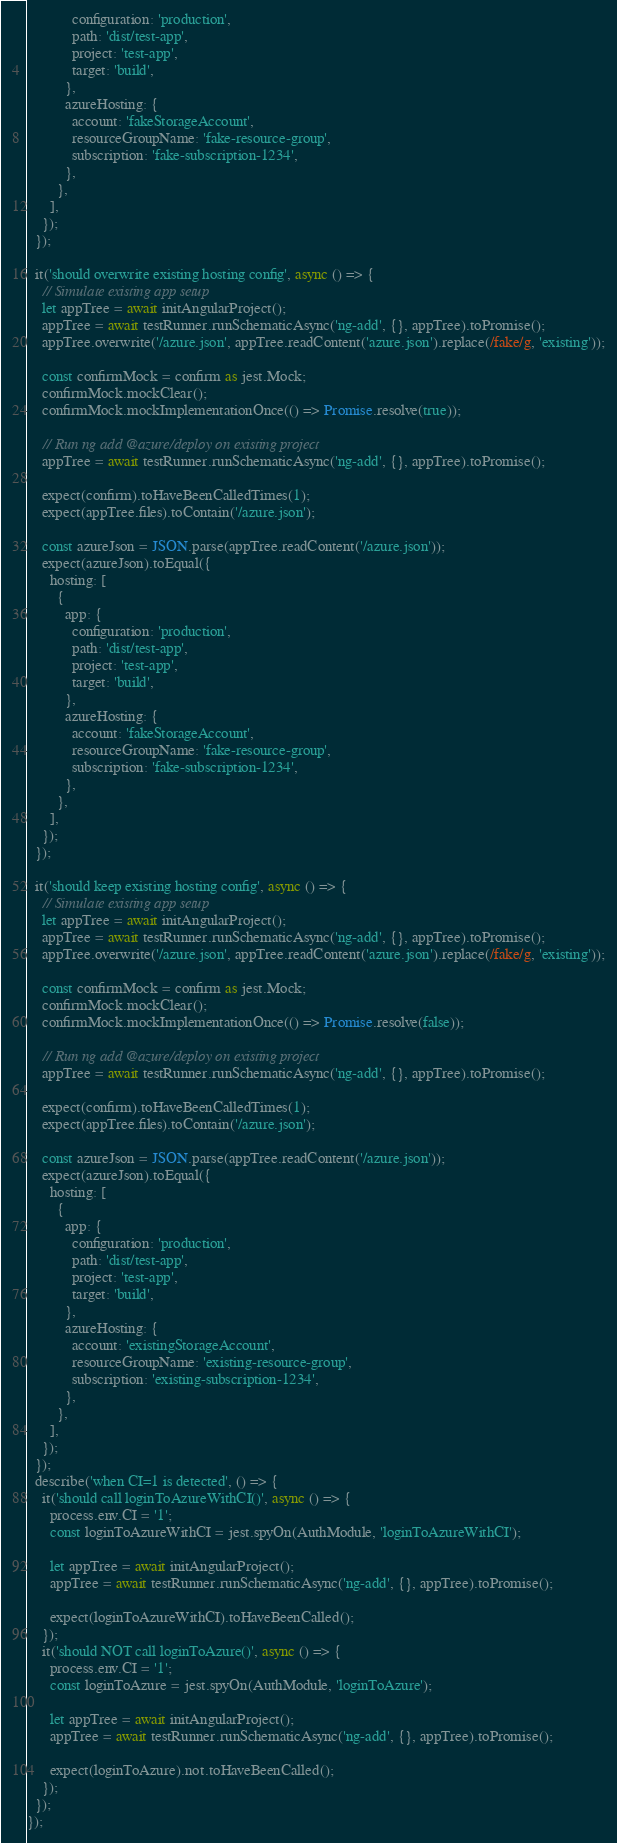Convert code to text. <code><loc_0><loc_0><loc_500><loc_500><_TypeScript_>            configuration: 'production',
            path: 'dist/test-app',
            project: 'test-app',
            target: 'build',
          },
          azureHosting: {
            account: 'fakeStorageAccount',
            resourceGroupName: 'fake-resource-group',
            subscription: 'fake-subscription-1234',
          },
        },
      ],
    });
  });

  it('should overwrite existing hosting config', async () => {
    // Simulate existing app setup
    let appTree = await initAngularProject();
    appTree = await testRunner.runSchematicAsync('ng-add', {}, appTree).toPromise();
    appTree.overwrite('/azure.json', appTree.readContent('azure.json').replace(/fake/g, 'existing'));

    const confirmMock = confirm as jest.Mock;
    confirmMock.mockClear();
    confirmMock.mockImplementationOnce(() => Promise.resolve(true));

    // Run ng add @azure/deploy on existing project
    appTree = await testRunner.runSchematicAsync('ng-add', {}, appTree).toPromise();

    expect(confirm).toHaveBeenCalledTimes(1);
    expect(appTree.files).toContain('/azure.json');

    const azureJson = JSON.parse(appTree.readContent('/azure.json'));
    expect(azureJson).toEqual({
      hosting: [
        {
          app: {
            configuration: 'production',
            path: 'dist/test-app',
            project: 'test-app',
            target: 'build',
          },
          azureHosting: {
            account: 'fakeStorageAccount',
            resourceGroupName: 'fake-resource-group',
            subscription: 'fake-subscription-1234',
          },
        },
      ],
    });
  });

  it('should keep existing hosting config', async () => {
    // Simulate existing app setup
    let appTree = await initAngularProject();
    appTree = await testRunner.runSchematicAsync('ng-add', {}, appTree).toPromise();
    appTree.overwrite('/azure.json', appTree.readContent('azure.json').replace(/fake/g, 'existing'));

    const confirmMock = confirm as jest.Mock;
    confirmMock.mockClear();
    confirmMock.mockImplementationOnce(() => Promise.resolve(false));

    // Run ng add @azure/deploy on existing project
    appTree = await testRunner.runSchematicAsync('ng-add', {}, appTree).toPromise();

    expect(confirm).toHaveBeenCalledTimes(1);
    expect(appTree.files).toContain('/azure.json');

    const azureJson = JSON.parse(appTree.readContent('/azure.json'));
    expect(azureJson).toEqual({
      hosting: [
        {
          app: {
            configuration: 'production',
            path: 'dist/test-app',
            project: 'test-app',
            target: 'build',
          },
          azureHosting: {
            account: 'existingStorageAccount',
            resourceGroupName: 'existing-resource-group',
            subscription: 'existing-subscription-1234',
          },
        },
      ],
    });
  });
  describe('when CI=1 is detected', () => {
    it('should call loginToAzureWithCI()', async () => {
      process.env.CI = '1';
      const loginToAzureWithCI = jest.spyOn(AuthModule, 'loginToAzureWithCI');

      let appTree = await initAngularProject();
      appTree = await testRunner.runSchematicAsync('ng-add', {}, appTree).toPromise();

      expect(loginToAzureWithCI).toHaveBeenCalled();
    });
    it('should NOT call loginToAzure()', async () => {
      process.env.CI = '1';
      const loginToAzure = jest.spyOn(AuthModule, 'loginToAzure');

      let appTree = await initAngularProject();
      appTree = await testRunner.runSchematicAsync('ng-add', {}, appTree).toPromise();

      expect(loginToAzure).not.toHaveBeenCalled();
    });
  });
});
</code> 